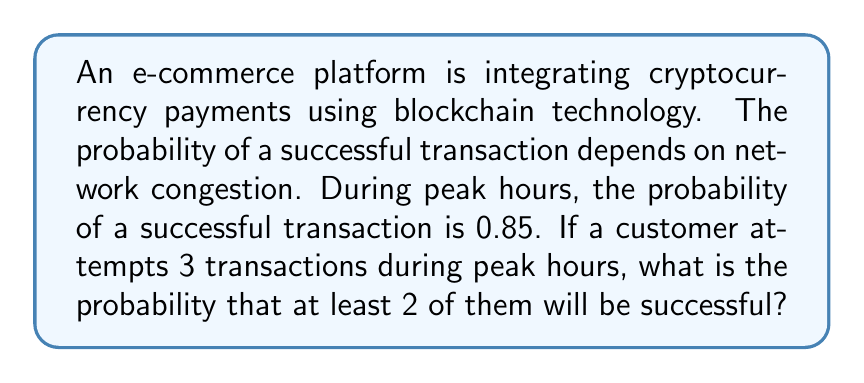Can you solve this math problem? Let's approach this step-by-step using the binomial probability formula:

1) Let $p$ be the probability of success for a single transaction. Here, $p = 0.85$.

2) We want at least 2 successes out of 3 trials. This means we need to calculate the probability of exactly 2 successes plus the probability of exactly 3 successes.

3) The binomial probability formula is:

   $P(X = k) = \binom{n}{k} p^k (1-p)^{n-k}$

   where $n$ is the number of trials, $k$ is the number of successes, $p$ is the probability of success on a single trial.

4) For exactly 2 successes out of 3 trials:

   $P(X = 2) = \binom{3}{2} (0.85)^2 (1-0.85)^{3-2}$
              $= 3 \cdot (0.85)^2 \cdot (0.15)^1$
              $= 3 \cdot 0.7225 \cdot 0.15$
              $= 0.325125$

5) For exactly 3 successes out of 3 trials:

   $P(X = 3) = \binom{3}{3} (0.85)^3 (1-0.85)^{3-3}$
              $= 1 \cdot (0.85)^3 \cdot (0.15)^0$
              $= 0.614125$

6) The probability of at least 2 successes is the sum of these probabilities:

   $P(X \geq 2) = P(X = 2) + P(X = 3)$
                $= 0.325125 + 0.614125$
                $= 0.93925$

Therefore, the probability of at least 2 successful transactions out of 3 attempts during peak hours is approximately 0.93925 or 93.925%.
Answer: 0.93925 